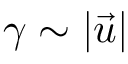<formula> <loc_0><loc_0><loc_500><loc_500>\gamma \sim | \vec { u } |</formula> 